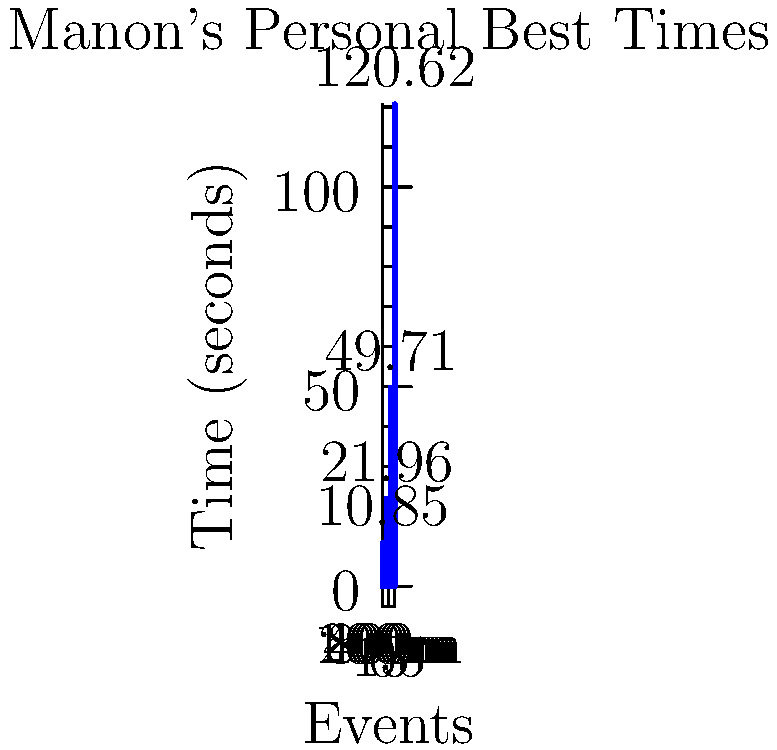Based on the diagram showing Manon's personal best times across different track events, which event shows the most significant difference in time compared to the others? To determine which event shows the most significant difference in time, we need to compare the times for each event:

1. 100m: 10.85 seconds
2. 200m: 21.96 seconds
3. 400m: 49.71 seconds
4. 800m: 120.62 seconds

Step 1: Calculate the differences between consecutive events:
- 200m - 100m = 21.96 - 10.85 = 11.11 seconds
- 400m - 200m = 49.71 - 21.96 = 27.75 seconds
- 800m - 400m = 120.62 - 49.71 = 70.91 seconds

Step 2: Compare the differences:
The largest difference is between the 400m and 800m events, with a difference of 70.91 seconds.

Step 3: Consider the context:
As a track and field coach, you would recognize that the 800m event is significantly longer than the others, which explains the large time difference.

Therefore, the 800m event shows the most significant difference in time compared to the others.
Answer: 800m 